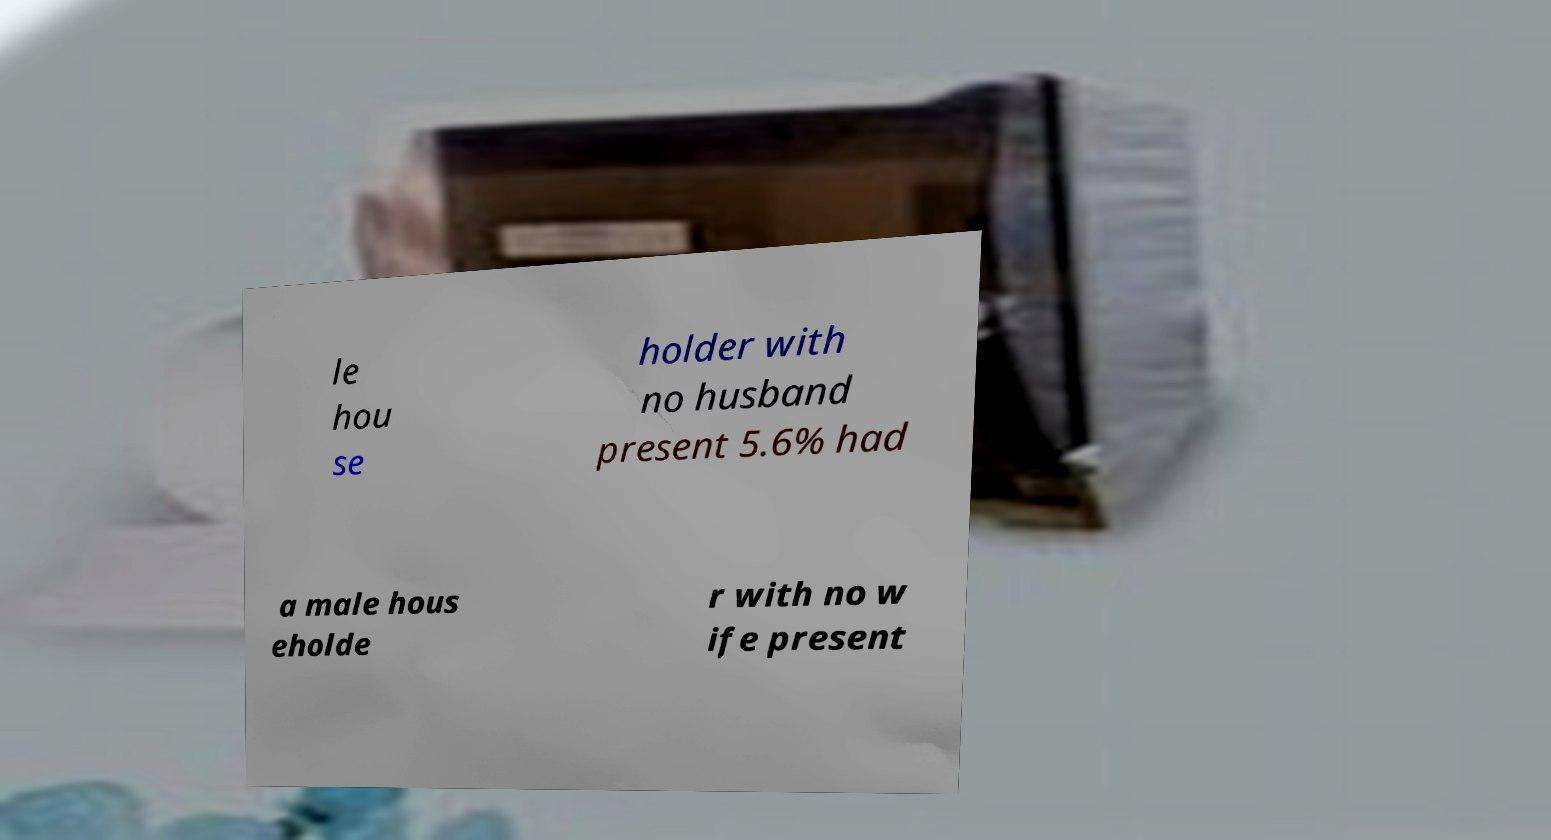For documentation purposes, I need the text within this image transcribed. Could you provide that? le hou se holder with no husband present 5.6% had a male hous eholde r with no w ife present 